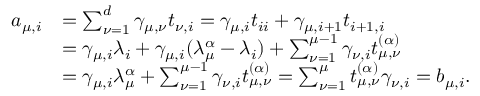<formula> <loc_0><loc_0><loc_500><loc_500>\begin{array} { r l } { a _ { \mu , i } } & { = \sum _ { \nu = 1 } ^ { d } \gamma _ { \mu , \nu } t _ { \nu , i } = \gamma _ { \mu , i } t _ { i i } + \gamma _ { \mu , i + 1 } t _ { i + 1 , i } } \\ & { = \gamma _ { \mu , i } \lambda _ { i } + \gamma _ { \mu , i } ( \lambda _ { \mu } ^ { \alpha } - \lambda _ { i } ) + \sum _ { \nu = 1 } ^ { \mu - 1 } \gamma _ { \nu , i } t _ { \mu , \nu } ^ { ( \alpha ) } } \\ & { = \gamma _ { \mu , i } \lambda _ { \mu } ^ { \alpha } + \sum _ { \nu = 1 } ^ { \mu - 1 } \gamma _ { \nu , i } t _ { \mu , \nu } ^ { ( \alpha ) } = \sum _ { \nu = 1 } ^ { \mu } t _ { \mu , \nu } ^ { ( \alpha ) } \gamma _ { \nu , i } = b _ { \mu , i } . } \end{array}</formula> 